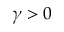<formula> <loc_0><loc_0><loc_500><loc_500>\gamma > 0</formula> 